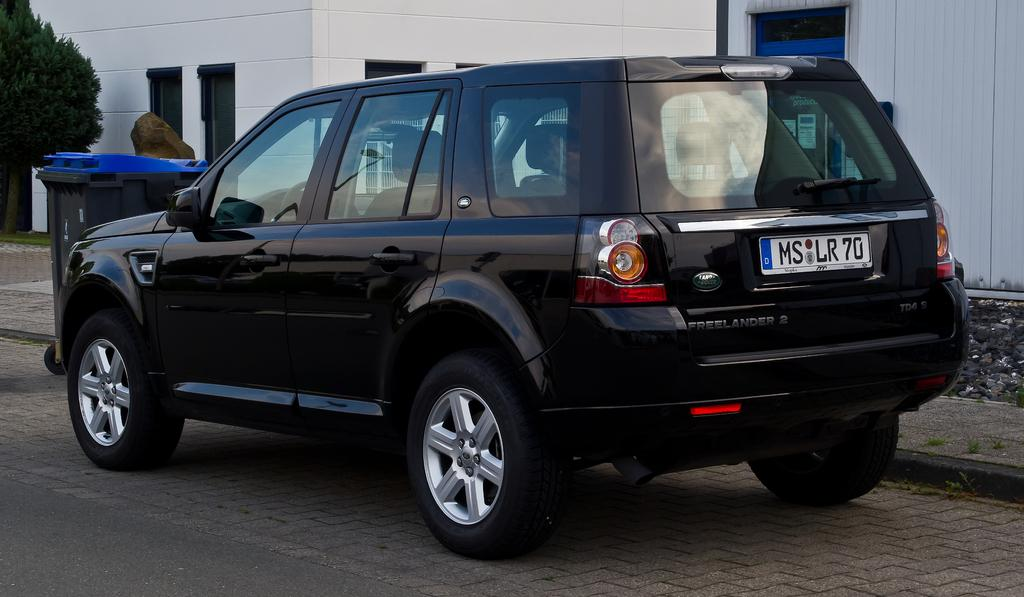What is the color of the vehicle in the image? The vehicle in the image is black. What can be seen in the background of the image? There is a building, a tree, a pole, and a garbage bin in the background of the image. Can you describe the type of vehicle in the image? The provided facts do not specify the type of vehicle, only its color. What type of grain is being harvested by the cows in the image? There are no cows or grain present in the image. Can you describe the bone structure of the animal in the image? There is no animal or bone structure visible in the image. 